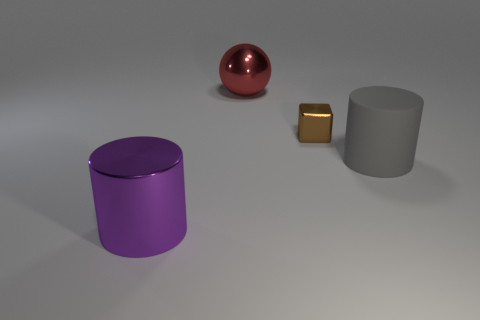Add 1 tiny brown objects. How many objects exist? 5 Subtract all balls. How many objects are left? 3 Subtract 0 cyan cylinders. How many objects are left? 4 Subtract all large brown shiny balls. Subtract all large things. How many objects are left? 1 Add 3 cylinders. How many cylinders are left? 5 Add 1 big gray rubber cylinders. How many big gray rubber cylinders exist? 2 